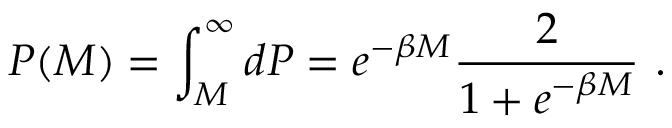<formula> <loc_0><loc_0><loc_500><loc_500>P ( M ) = \int _ { M } ^ { \infty } d P = e ^ { - \beta M } \frac { 2 } { 1 + e ^ { - \beta M } } \, .</formula> 